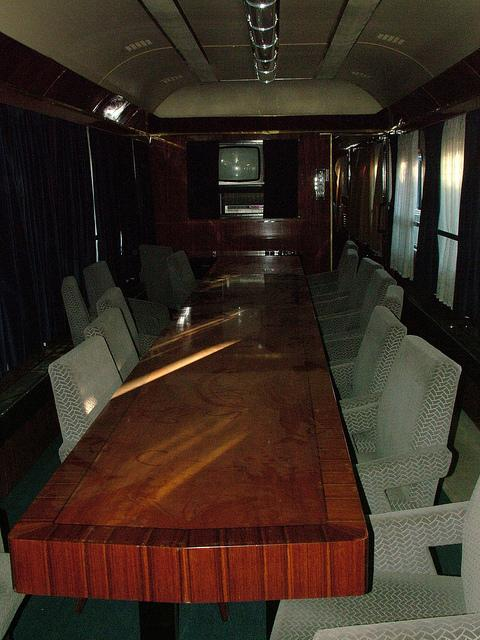The room here might be found where? train 